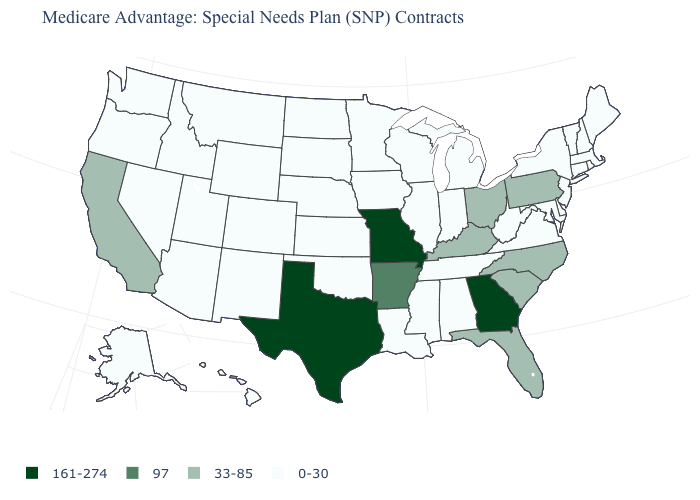How many symbols are there in the legend?
Short answer required. 4. What is the value of Iowa?
Concise answer only. 0-30. Name the states that have a value in the range 0-30?
Give a very brief answer. Alaska, Alabama, Arizona, Colorado, Connecticut, Delaware, Hawaii, Iowa, Idaho, Illinois, Indiana, Kansas, Louisiana, Massachusetts, Maryland, Maine, Michigan, Minnesota, Mississippi, Montana, North Dakota, Nebraska, New Hampshire, New Jersey, New Mexico, Nevada, New York, Oklahoma, Oregon, Rhode Island, South Dakota, Tennessee, Utah, Virginia, Vermont, Washington, Wisconsin, West Virginia, Wyoming. What is the value of Oklahoma?
Keep it brief. 0-30. What is the value of Arkansas?
Write a very short answer. 97. What is the value of Washington?
Concise answer only. 0-30. What is the value of Pennsylvania?
Short answer required. 33-85. What is the highest value in the MidWest ?
Concise answer only. 161-274. What is the lowest value in states that border Arizona?
Quick response, please. 0-30. Does Louisiana have the lowest value in the USA?
Answer briefly. Yes. What is the value of Michigan?
Be succinct. 0-30. Does the first symbol in the legend represent the smallest category?
Concise answer only. No. Which states have the lowest value in the West?
Be succinct. Alaska, Arizona, Colorado, Hawaii, Idaho, Montana, New Mexico, Nevada, Oregon, Utah, Washington, Wyoming. Does the first symbol in the legend represent the smallest category?
Quick response, please. No. Name the states that have a value in the range 161-274?
Concise answer only. Georgia, Missouri, Texas. 